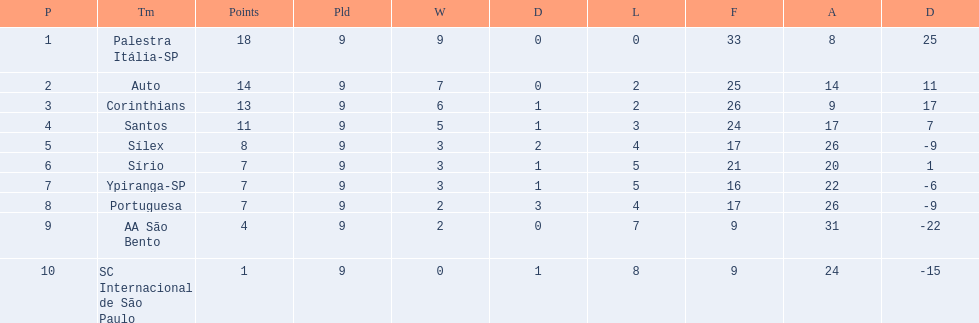How many teams played football in brazil during the year 1926? Palestra Itália-SP, Auto, Corinthians, Santos, Sílex, Sírio, Ypiranga-SP, Portuguesa, AA São Bento, SC Internacional de São Paulo. What was the highest number of games won during the 1926 season? 9. Which team was in the top spot with 9 wins for the 1926 season? Palestra Itália-SP. 